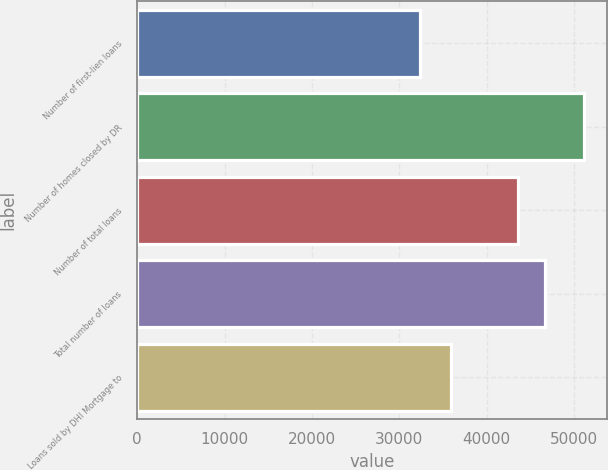<chart> <loc_0><loc_0><loc_500><loc_500><bar_chart><fcel>Number of first-lien loans<fcel>Number of homes closed by DR<fcel>Number of total loans<fcel>Total number of loans<fcel>Loans sold by DHI Mortgage to<nl><fcel>32404<fcel>51172<fcel>43581<fcel>46648<fcel>35962<nl></chart> 